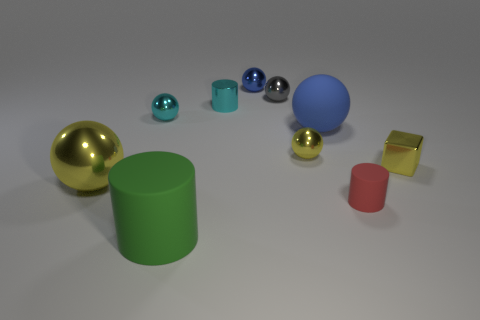There is a thing that is on the left side of the red rubber thing and in front of the big yellow metal object; what material is it made of?
Offer a very short reply. Rubber. Are there any other things that have the same shape as the red rubber thing?
Keep it short and to the point. Yes. What number of objects are both to the right of the large yellow sphere and on the left side of the big blue rubber object?
Give a very brief answer. 6. What is the small blue ball made of?
Provide a succinct answer. Metal. Are there the same number of small shiny cylinders that are on the right side of the large blue object and small yellow metallic spheres?
Ensure brevity in your answer.  No. How many cyan objects have the same shape as the tiny blue metal thing?
Ensure brevity in your answer.  1. Do the tiny rubber object and the green rubber thing have the same shape?
Provide a short and direct response. Yes. How many things are either matte cylinders that are to the left of the small rubber object or small red matte balls?
Offer a very short reply. 1. The cyan metal object that is in front of the cylinder that is behind the metal thing in front of the small block is what shape?
Ensure brevity in your answer.  Sphere. What shape is the large thing that is the same material as the big green cylinder?
Give a very brief answer. Sphere. 